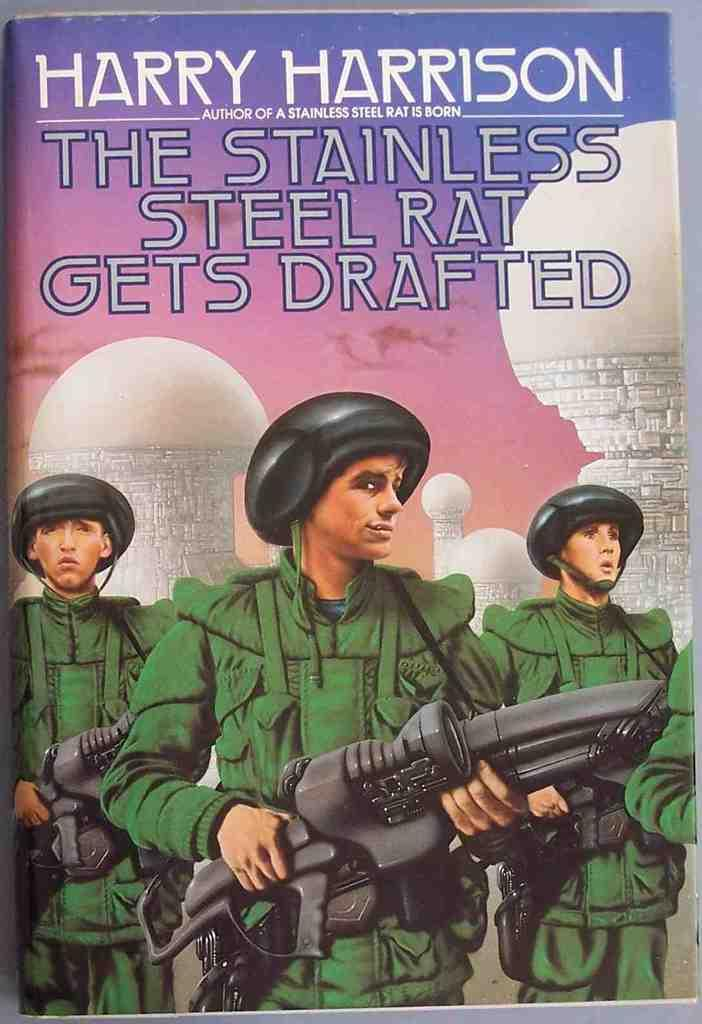<image>
Render a clear and concise summary of the photo. A book by Harry Harrison called The Stainless Steel Rat Get Drafted. 